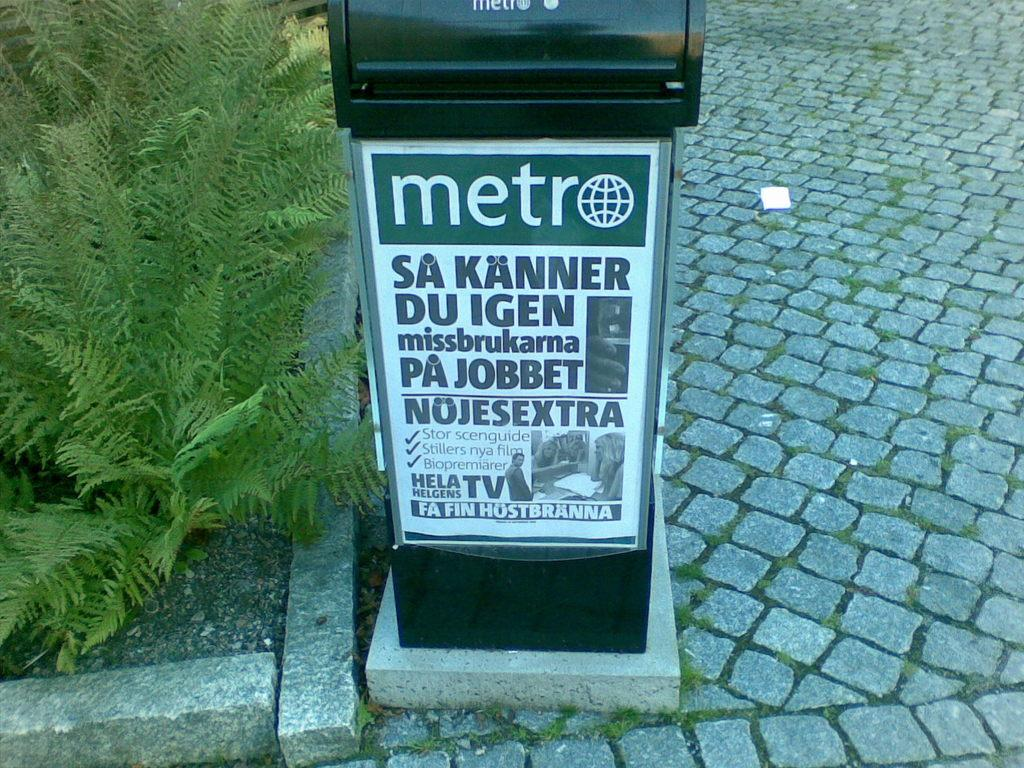<image>
Provide a brief description of the given image. a mailbox has an advertisement for metro stuck to it 